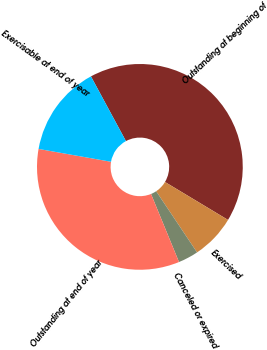Convert chart. <chart><loc_0><loc_0><loc_500><loc_500><pie_chart><fcel>Outstanding at beginning of<fcel>Exercised<fcel>Canceled or expired<fcel>Outstanding at end of year<fcel>Exercisable at end of year<nl><fcel>41.51%<fcel>7.0%<fcel>3.17%<fcel>34.0%<fcel>14.32%<nl></chart> 